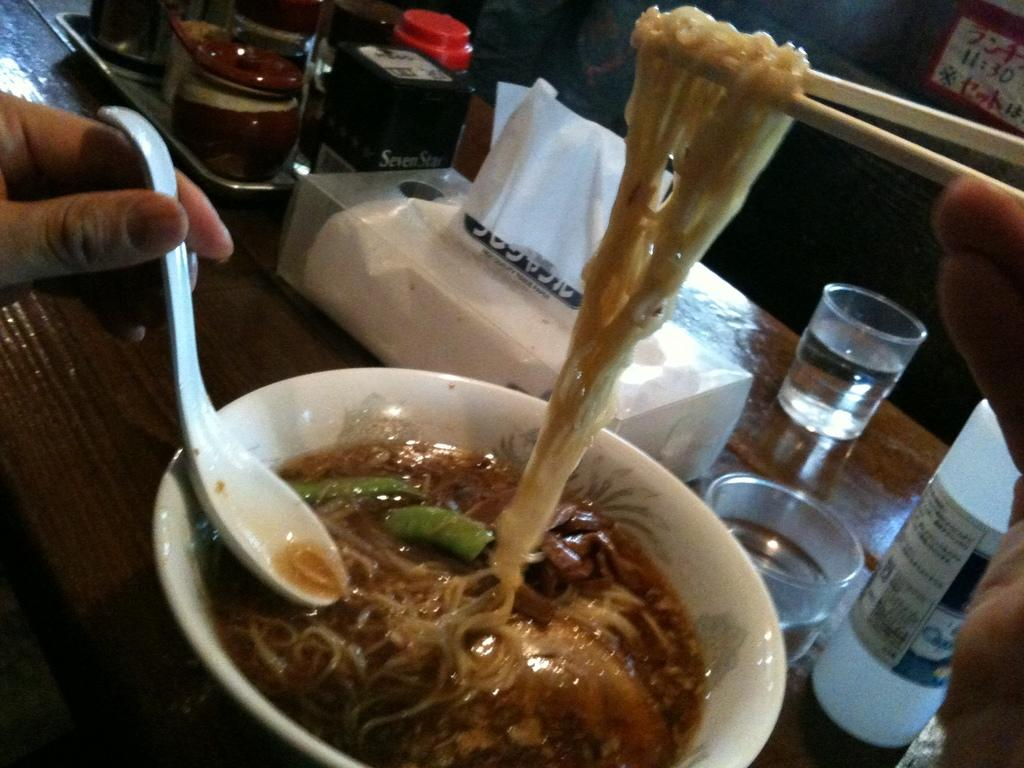What is in the bowl that is visible in the image? The bowl contains food. What utensil is present in the image? There is a spoon in the image. Who is using the spoon in the image? A person is holding the spoon. What item is present for wiping or blowing one's nose? There is a tissue paper box in the image. What type of container is present for holding a beverage? There is a glass in the image. What type of furniture is present in the image? There is a table in the image. What type of container is present for holding a liquid? There is a bottle in the image. How many chickens are present in the image? There are no chickens present in the image. What channel is the person watching on the television in the image? There is no television present in the image. 